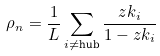Convert formula to latex. <formula><loc_0><loc_0><loc_500><loc_500>\rho _ { n } = \frac { 1 } { L } \sum _ { i \neq \text {hub} } \frac { z k _ { i } } { 1 - z k _ { i } }</formula> 